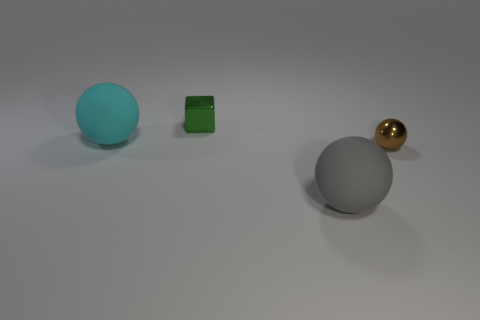There is a thing that is the same size as the brown sphere; what is it made of?
Your answer should be very brief. Metal. How big is the matte sphere in front of the tiny sphere that is on the right side of the small metal cube behind the cyan rubber ball?
Make the answer very short. Large. What number of red things are either rubber things or small balls?
Offer a terse response. 0. What number of green objects are the same size as the brown shiny thing?
Offer a very short reply. 1. Are the tiny object in front of the tiny green metallic object and the tiny green block made of the same material?
Provide a short and direct response. Yes. There is a large matte sphere that is in front of the large cyan ball; are there any small green metallic cubes that are in front of it?
Ensure brevity in your answer.  No. There is another tiny thing that is the same shape as the cyan thing; what material is it?
Keep it short and to the point. Metal. Are there more small metal things that are in front of the cyan matte ball than large cyan balls that are on the right side of the big gray rubber object?
Provide a short and direct response. Yes. There is a small thing that is made of the same material as the block; what is its shape?
Your answer should be compact. Sphere. Is the number of large rubber balls that are left of the green metallic object greater than the number of big green shiny objects?
Offer a very short reply. Yes. 